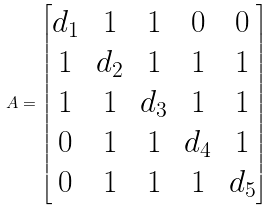<formula> <loc_0><loc_0><loc_500><loc_500>A = \begin{bmatrix} d _ { 1 } & 1 & 1 & 0 & 0 \\ 1 & d _ { 2 } & 1 & 1 & 1 \\ 1 & 1 & d _ { 3 } & 1 & 1 \\ 0 & 1 & 1 & d _ { 4 } & 1 \\ 0 & 1 & 1 & 1 & d _ { 5 } \end{bmatrix}</formula> 